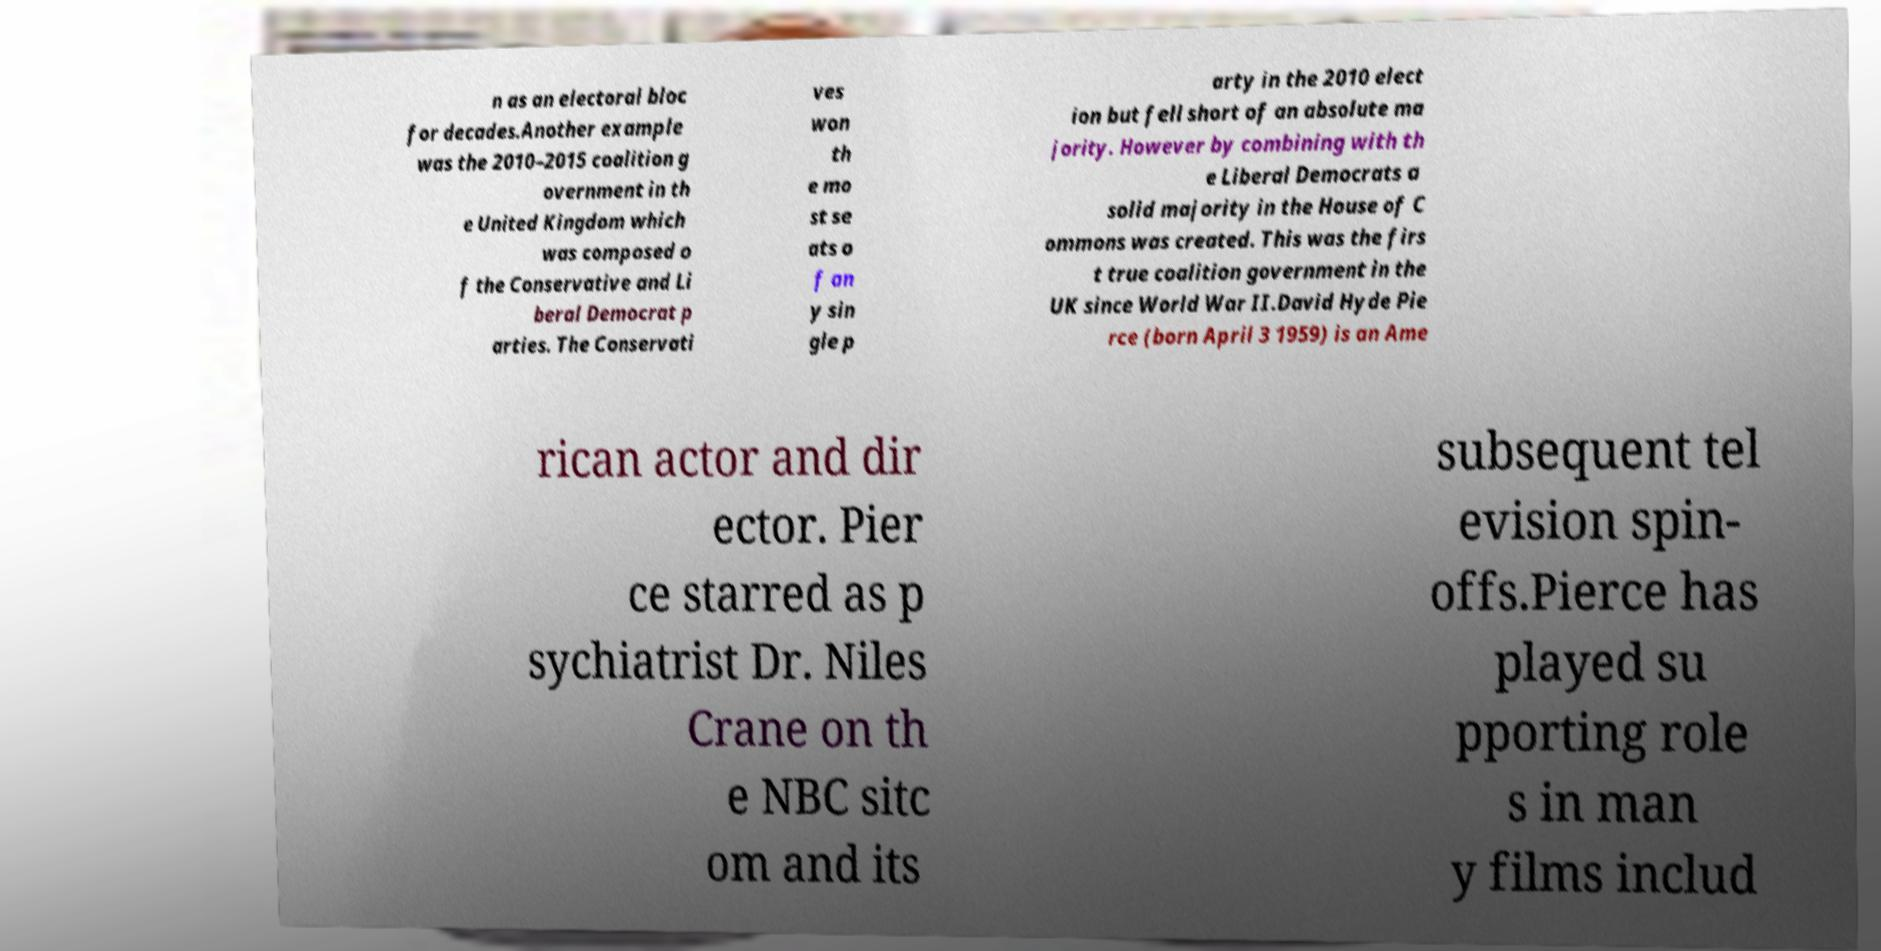I need the written content from this picture converted into text. Can you do that? n as an electoral bloc for decades.Another example was the 2010–2015 coalition g overnment in th e United Kingdom which was composed o f the Conservative and Li beral Democrat p arties. The Conservati ves won th e mo st se ats o f an y sin gle p arty in the 2010 elect ion but fell short of an absolute ma jority. However by combining with th e Liberal Democrats a solid majority in the House of C ommons was created. This was the firs t true coalition government in the UK since World War II.David Hyde Pie rce (born April 3 1959) is an Ame rican actor and dir ector. Pier ce starred as p sychiatrist Dr. Niles Crane on th e NBC sitc om and its subsequent tel evision spin- offs.Pierce has played su pporting role s in man y films includ 